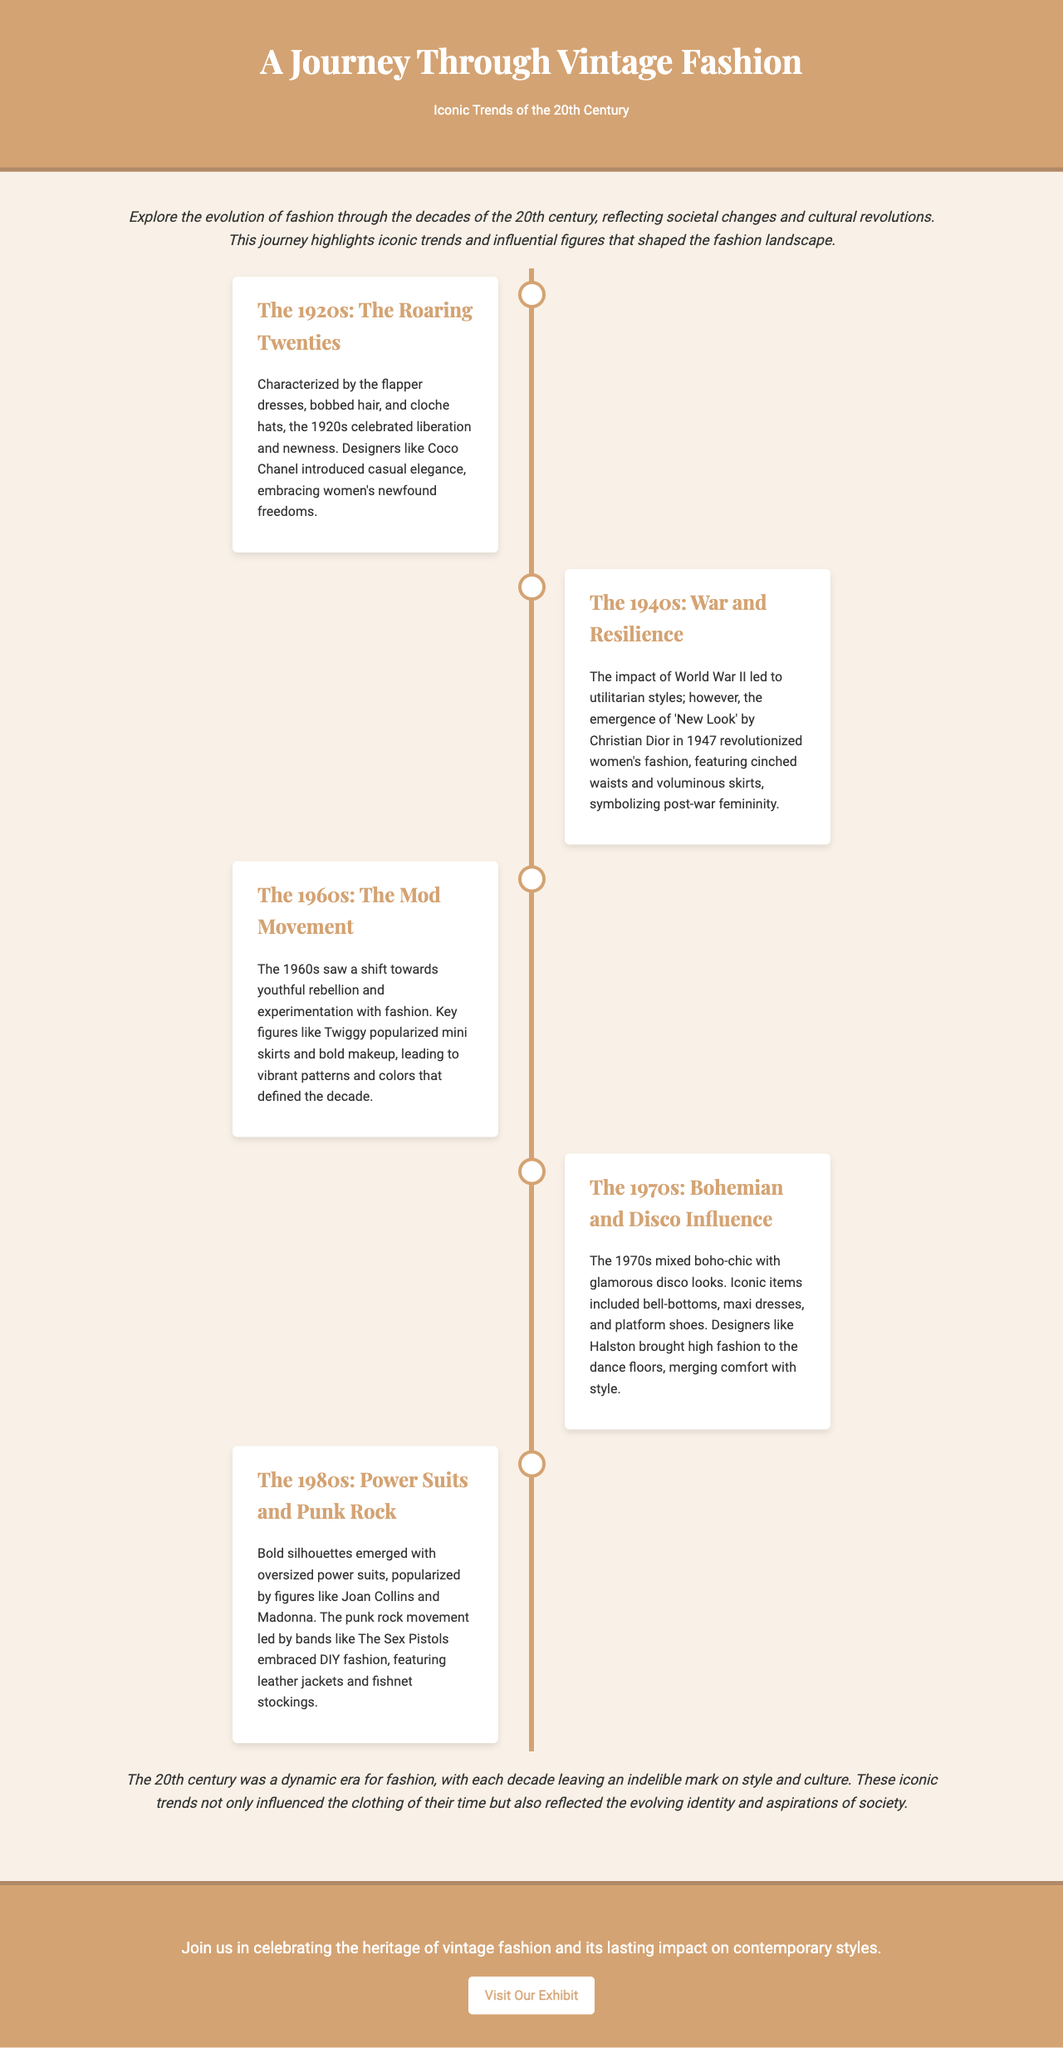What is the title of the brochure? The title of the brochure is prominently displayed at the top of the document.
Answer: A Journey Through Vintage Fashion What decade is characterized by flapper dresses? The document specifies that flapper dresses were iconic during this decade.
Answer: The 1920s Who introduced the 'New Look' in 1947? The document identifies the designer who introduced this significant fashion trend.
Answer: Christian Dior Which movement popularized mini skirts? The document mentions a key figure associated with this fashion trend in the specified decade.
Answer: The Mod Movement What fashion trend is associated with the 1980s? This decade is described in the document focusing on bold silhouettes and specific styles.
Answer: Power Suits What type of fashion styles emerged during the 1940s? The document describes the general style influence of the 1940s related to a significant event.
Answer: Utilitarian styles What iconic items were featured in the 1970s? The document lists prominent fashion items from this decade.
Answer: Bell-bottoms, maxi dresses, platform shoes In what way did the fashion reflect societal changes? The document mentions the impact of societal changes on fashion across the decades.
Answer: Through the evolution of fashion What is the purpose of the brochure? The brochure aims to inform about specific trends and their cultural significance.
Answer: To celebrate the heritage of vintage fashion 